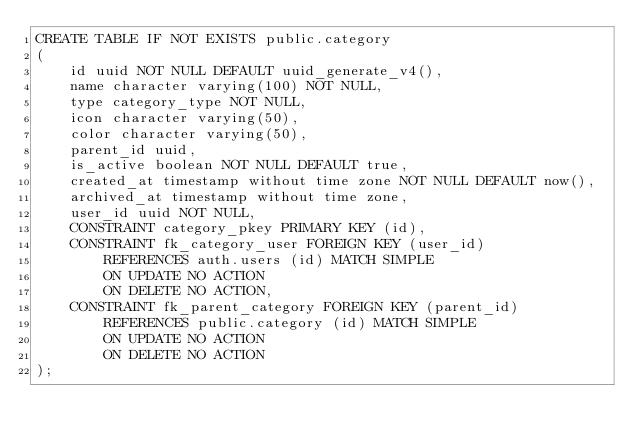Convert code to text. <code><loc_0><loc_0><loc_500><loc_500><_SQL_>CREATE TABLE IF NOT EXISTS public.category
(
    id uuid NOT NULL DEFAULT uuid_generate_v4(),
    name character varying(100) NOT NULL,
    type category_type NOT NULL,
    icon character varying(50),
    color character varying(50),
    parent_id uuid,
    is_active boolean NOT NULL DEFAULT true,
    created_at timestamp without time zone NOT NULL DEFAULT now(),
    archived_at timestamp without time zone,
    user_id uuid NOT NULL,
    CONSTRAINT category_pkey PRIMARY KEY (id),
    CONSTRAINT fk_category_user FOREIGN KEY (user_id)
        REFERENCES auth.users (id) MATCH SIMPLE
        ON UPDATE NO ACTION
        ON DELETE NO ACTION,
    CONSTRAINT fk_parent_category FOREIGN KEY (parent_id)
        REFERENCES public.category (id) MATCH SIMPLE
        ON UPDATE NO ACTION
        ON DELETE NO ACTION
);

</code> 